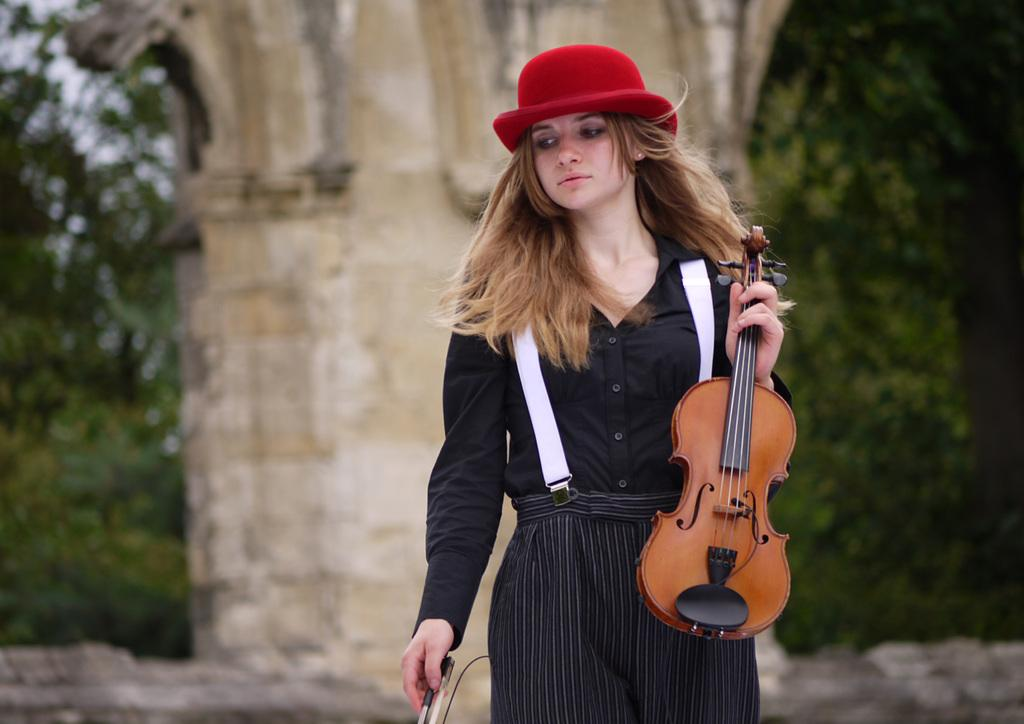Who is the main subject in the image? There is a woman in the image. What is the woman doing in the image? The woman is standing in the image. What object is the woman holding in her hand? The woman is holding a violin in her hand. Can you describe the background of the image? The background of the image is blurred. How many clocks can be seen in the image? There are no clocks visible in the image. What season is depicted in the image? The provided facts do not mention any season, so it cannot be determined from the image. 